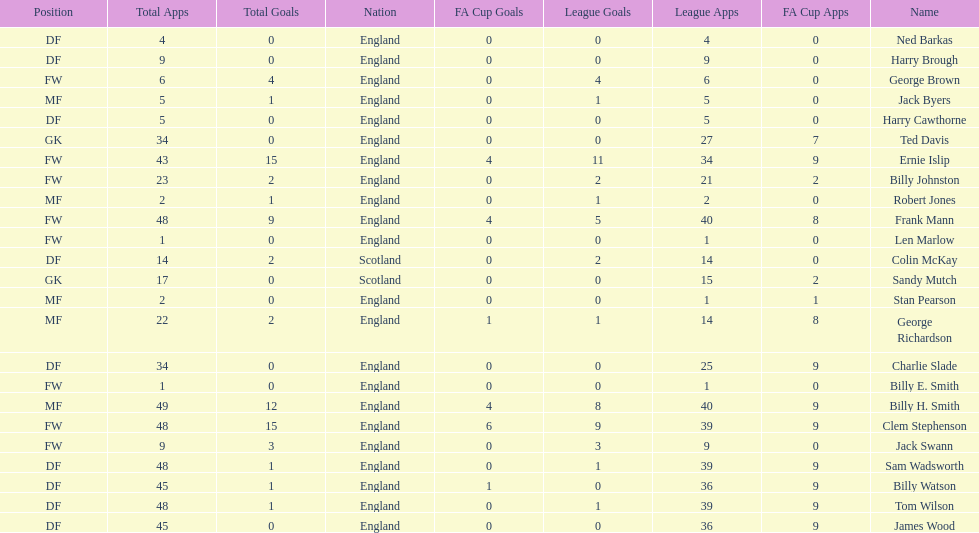What are the number of league apps ted davis has? 27. 